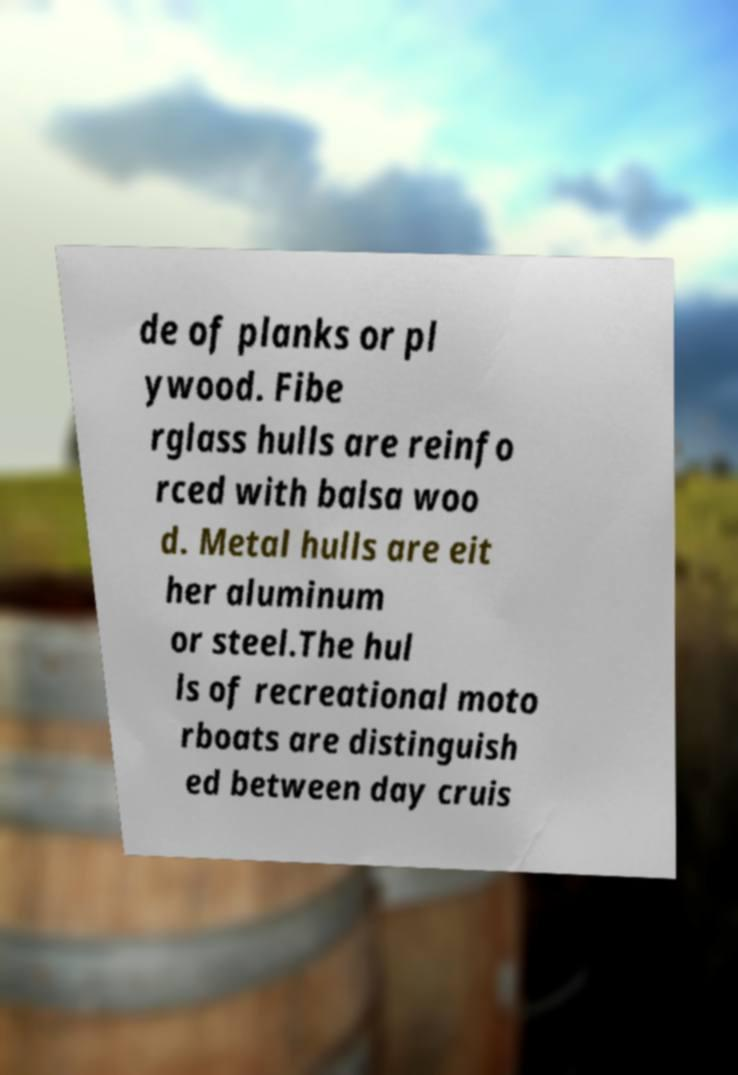For documentation purposes, I need the text within this image transcribed. Could you provide that? de of planks or pl ywood. Fibe rglass hulls are reinfo rced with balsa woo d. Metal hulls are eit her aluminum or steel.The hul ls of recreational moto rboats are distinguish ed between day cruis 